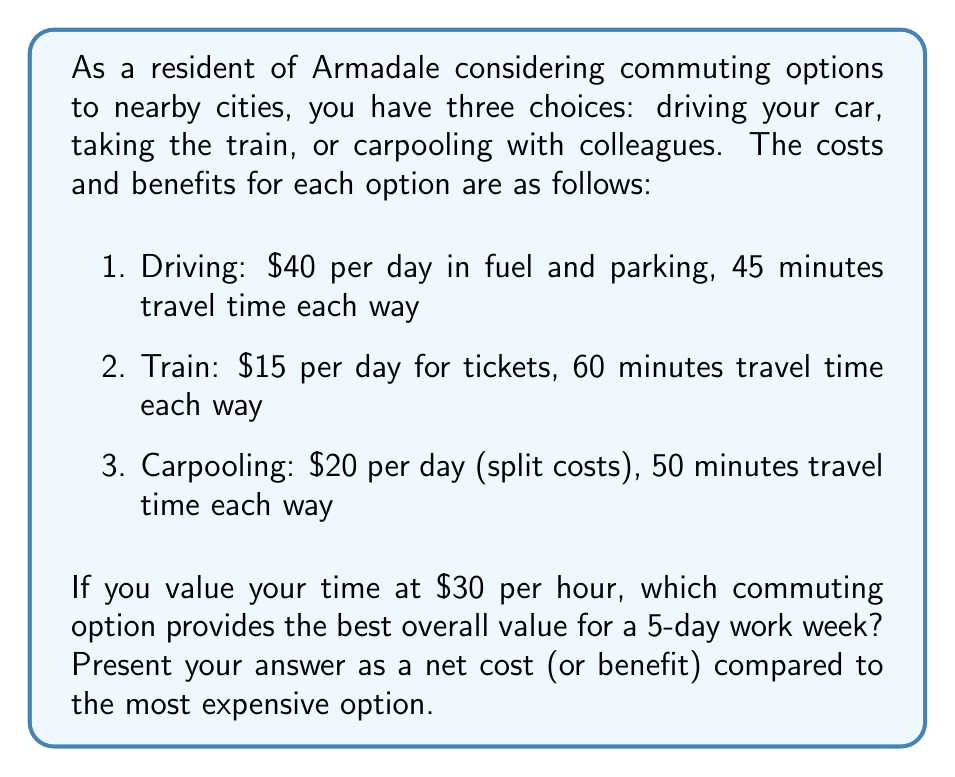Teach me how to tackle this problem. To solve this problem, we need to calculate the total cost for each option, including both monetary expenses and the value of time spent commuting. Then, we'll compare the options to find the best value.

Let's calculate the weekly cost for each option:

1. Driving:
   Monetary cost: $40 * 5 days = $200
   Time cost: (45 min * 2 ways * 5 days) / 60 min/hour * $30/hour = $225
   Total cost: $200 + $225 = $425

2. Train:
   Monetary cost: $15 * 5 days = $75
   Time cost: (60 min * 2 ways * 5 days) / 60 min/hour * $30/hour = $300
   Total cost: $75 + $300 = $375

3. Carpooling:
   Monetary cost: $20 * 5 days = $100
   Time cost: (50 min * 2 ways * 5 days) / 60 min/hour * $30/hour = $250
   Total cost: $100 + $250 = $350

Now, let's compare the options:

Driving is the most expensive option at $425 per week.
Train costs $375 per week, which is $50 less than driving.
Carpooling costs $350 per week, which is $75 less than driving.

Therefore, carpooling provides the best overall value, saving $75 per week compared to the most expensive option (driving).
Answer: Carpooling provides the best overall value, with a net benefit of $75 per week compared to the most expensive option (driving). 